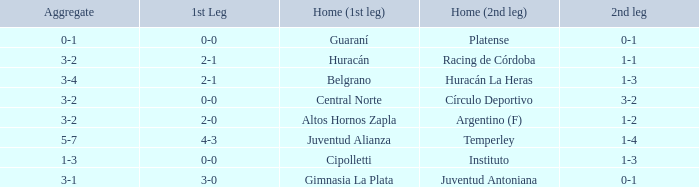Who played at home for the second leg with a score of 0-1 and tied 0-0 in the first leg? Platense. 